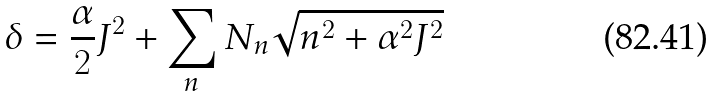Convert formula to latex. <formula><loc_0><loc_0><loc_500><loc_500>\delta = \frac { \alpha } { 2 } J ^ { 2 } + \sum _ { n } N _ { n } \sqrt { n ^ { 2 } + \alpha ^ { 2 } J ^ { 2 } }</formula> 